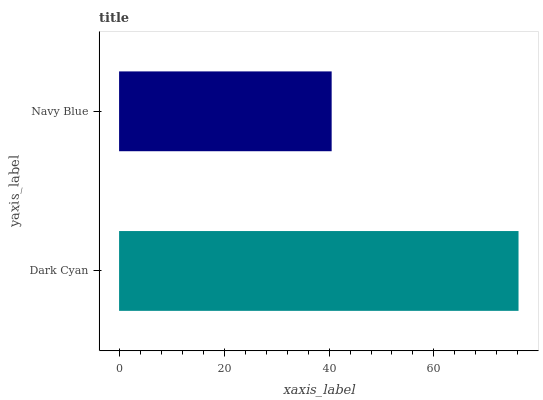Is Navy Blue the minimum?
Answer yes or no. Yes. Is Dark Cyan the maximum?
Answer yes or no. Yes. Is Navy Blue the maximum?
Answer yes or no. No. Is Dark Cyan greater than Navy Blue?
Answer yes or no. Yes. Is Navy Blue less than Dark Cyan?
Answer yes or no. Yes. Is Navy Blue greater than Dark Cyan?
Answer yes or no. No. Is Dark Cyan less than Navy Blue?
Answer yes or no. No. Is Dark Cyan the high median?
Answer yes or no. Yes. Is Navy Blue the low median?
Answer yes or no. Yes. Is Navy Blue the high median?
Answer yes or no. No. Is Dark Cyan the low median?
Answer yes or no. No. 